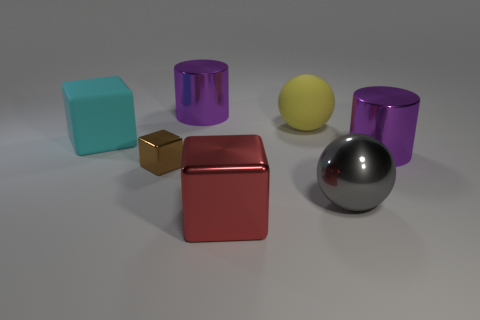There is a large gray ball right of the large metallic cube; what is it made of?
Make the answer very short. Metal. There is a cyan object that is the same shape as the tiny brown thing; what is its size?
Provide a short and direct response. Large. Is the number of large gray metal spheres that are behind the brown metallic block less than the number of cylinders?
Offer a terse response. Yes. Are any tiny things visible?
Your answer should be compact. Yes. The rubber thing that is the same shape as the gray metallic object is what color?
Your answer should be very brief. Yellow. There is a cylinder behind the cyan rubber object; is its color the same as the large matte sphere?
Make the answer very short. No. Does the red object have the same size as the cyan cube?
Make the answer very short. Yes. The red thing that is made of the same material as the small block is what shape?
Your answer should be compact. Cube. What number of other objects are there of the same shape as the yellow thing?
Your response must be concise. 1. What shape is the big thing to the left of the large purple cylinder behind the large purple thing on the right side of the large gray thing?
Your answer should be very brief. Cube. 